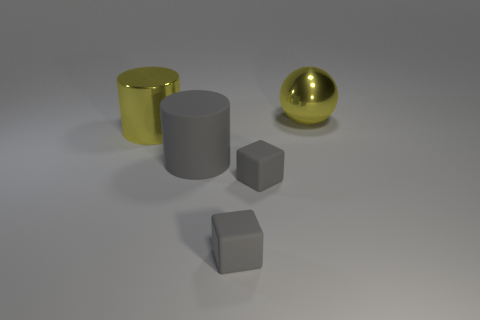What is the size of the yellow thing that is behind the yellow metallic object that is on the left side of the sphere?
Offer a terse response. Large. What number of yellow metal objects have the same shape as the large gray thing?
Your answer should be compact. 1. Do the large shiny ball and the big metallic cylinder have the same color?
Keep it short and to the point. Yes. Is there any other thing that is the same shape as the large gray thing?
Your response must be concise. Yes. Are there any big metal cylinders of the same color as the big metallic sphere?
Ensure brevity in your answer.  Yes. Does the yellow thing on the left side of the large gray matte thing have the same material as the ball that is to the right of the big gray matte thing?
Keep it short and to the point. Yes. What is the color of the sphere?
Ensure brevity in your answer.  Yellow. What is the size of the shiny thing that is on the right side of the gray cylinder that is in front of the yellow object that is to the left of the metal ball?
Make the answer very short. Large. What number of other objects are there of the same size as the yellow metal cylinder?
Give a very brief answer. 2. What number of other objects are the same material as the big gray object?
Your response must be concise. 2. 